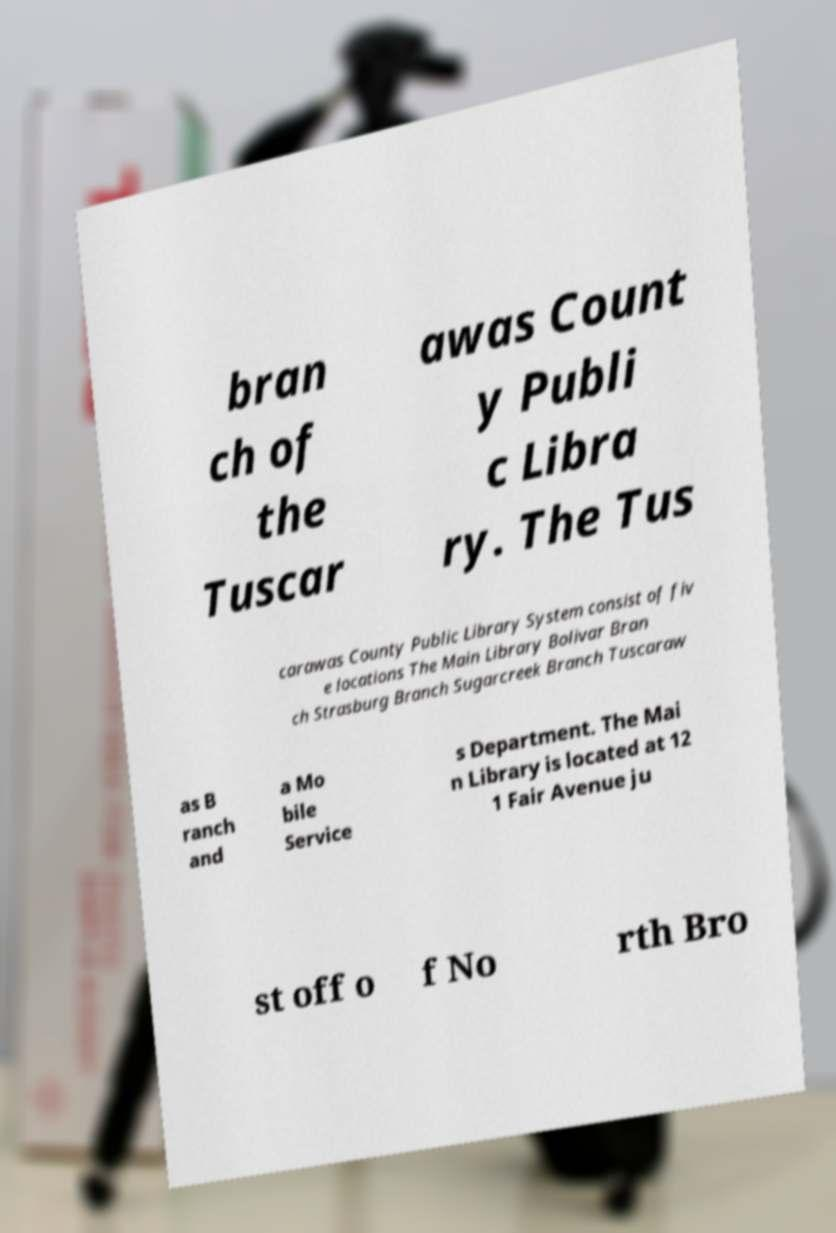Please read and relay the text visible in this image. What does it say? bran ch of the Tuscar awas Count y Publi c Libra ry. The Tus carawas County Public Library System consist of fiv e locations The Main Library Bolivar Bran ch Strasburg Branch Sugarcreek Branch Tuscaraw as B ranch and a Mo bile Service s Department. The Mai n Library is located at 12 1 Fair Avenue ju st off o f No rth Bro 